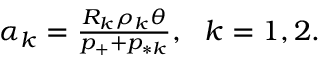Convert formula to latex. <formula><loc_0><loc_0><loc_500><loc_500>\begin{array} { r } { \alpha _ { k } = \frac { R _ { k } \rho _ { k } \theta } { p _ { + } + p _ { * k } } , \ \ k = 1 , 2 . } \end{array}</formula> 